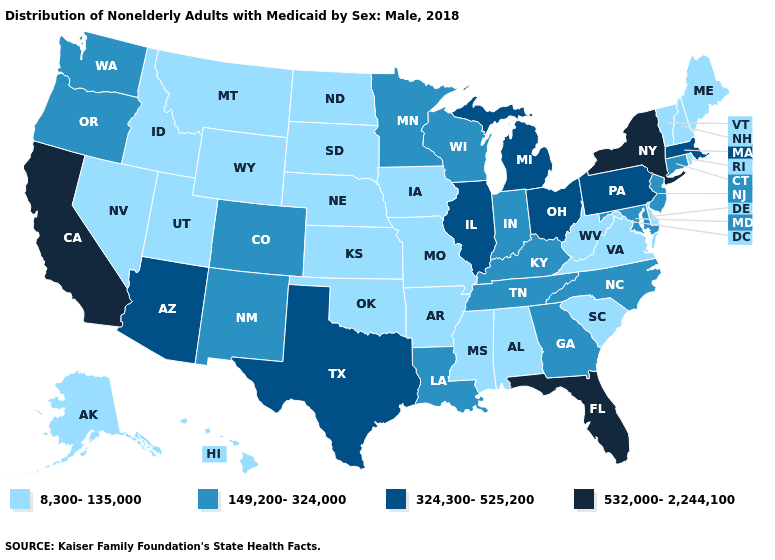What is the value of New York?
Keep it brief. 532,000-2,244,100. Among the states that border Indiana , which have the highest value?
Concise answer only. Illinois, Michigan, Ohio. Name the states that have a value in the range 8,300-135,000?
Short answer required. Alabama, Alaska, Arkansas, Delaware, Hawaii, Idaho, Iowa, Kansas, Maine, Mississippi, Missouri, Montana, Nebraska, Nevada, New Hampshire, North Dakota, Oklahoma, Rhode Island, South Carolina, South Dakota, Utah, Vermont, Virginia, West Virginia, Wyoming. Name the states that have a value in the range 532,000-2,244,100?
Be succinct. California, Florida, New York. What is the highest value in states that border Virginia?
Be succinct. 149,200-324,000. What is the value of Michigan?
Write a very short answer. 324,300-525,200. Does the map have missing data?
Answer briefly. No. Does California have the highest value in the USA?
Keep it brief. Yes. Among the states that border Maine , which have the highest value?
Short answer required. New Hampshire. Among the states that border Maryland , does West Virginia have the lowest value?
Quick response, please. Yes. Name the states that have a value in the range 532,000-2,244,100?
Concise answer only. California, Florida, New York. What is the value of West Virginia?
Answer briefly. 8,300-135,000. Does Indiana have the lowest value in the USA?
Write a very short answer. No. Name the states that have a value in the range 532,000-2,244,100?
Concise answer only. California, Florida, New York. 